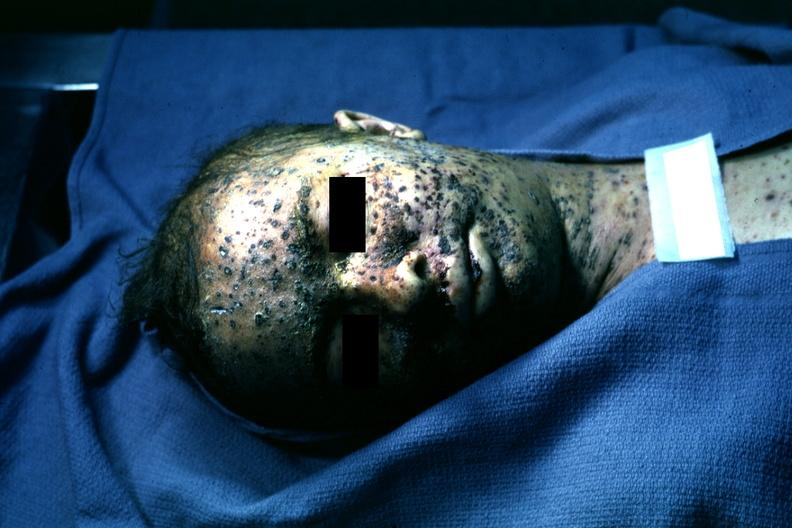s temporal muscle hemorrhage present?
Answer the question using a single word or phrase. No 